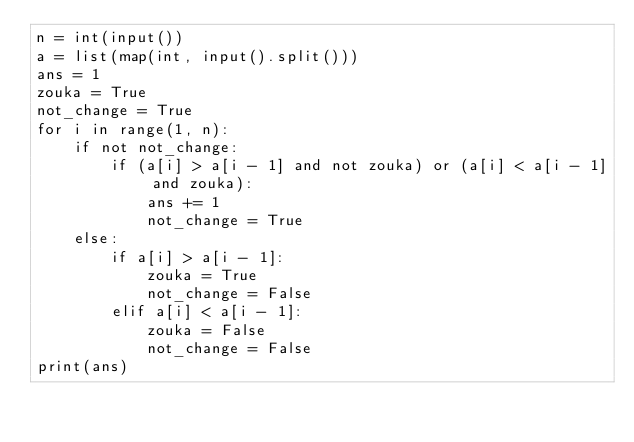<code> <loc_0><loc_0><loc_500><loc_500><_Python_>n = int(input())
a = list(map(int, input().split()))
ans = 1
zouka = True
not_change = True
for i in range(1, n):
    if not not_change:
        if (a[i] > a[i - 1] and not zouka) or (a[i] < a[i - 1] and zouka):
            ans += 1
            not_change = True
    else:
        if a[i] > a[i - 1]:
            zouka = True
            not_change = False
        elif a[i] < a[i - 1]:
            zouka = False
            not_change = False
print(ans)</code> 